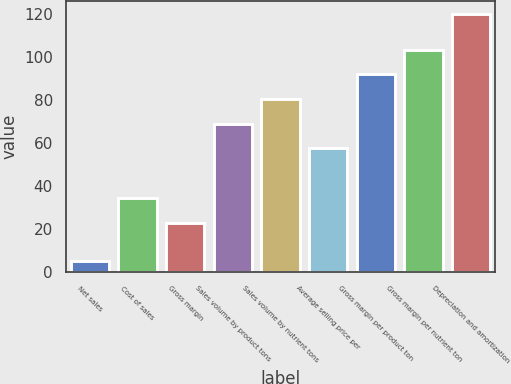Convert chart. <chart><loc_0><loc_0><loc_500><loc_500><bar_chart><fcel>Net sales<fcel>Cost of sales<fcel>Gross margin<fcel>Sales volume by product tons<fcel>Sales volume by nutrient tons<fcel>Average selling price per<fcel>Gross margin per product ton<fcel>Gross margin per nutrient ton<fcel>Depreciation and amortization<nl><fcel>5<fcel>34.5<fcel>23<fcel>69<fcel>80.5<fcel>57.5<fcel>92<fcel>103.5<fcel>120<nl></chart> 